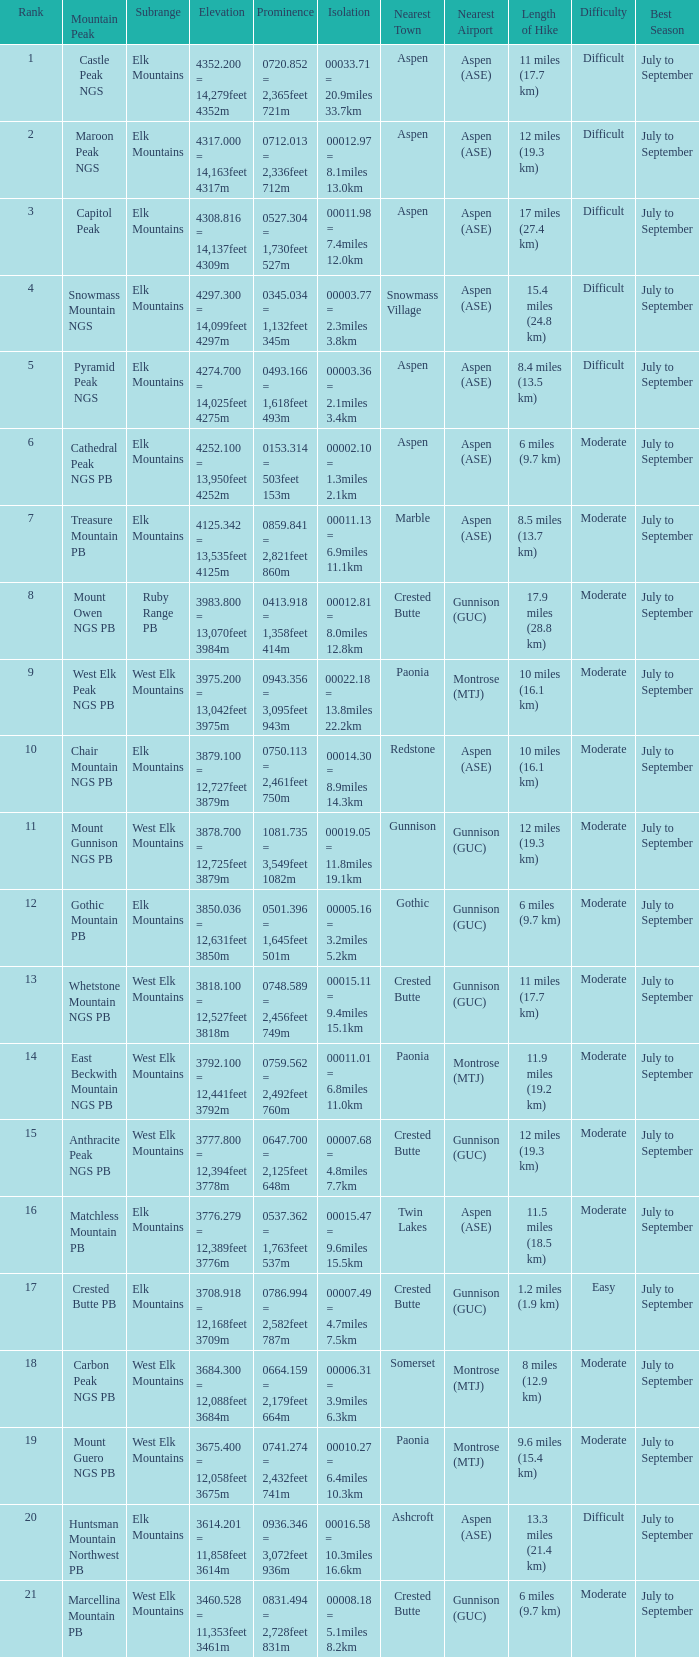Name the Prominence of the Mountain Peak of matchless mountain pb? 0537.362 = 1,763feet 537m. 